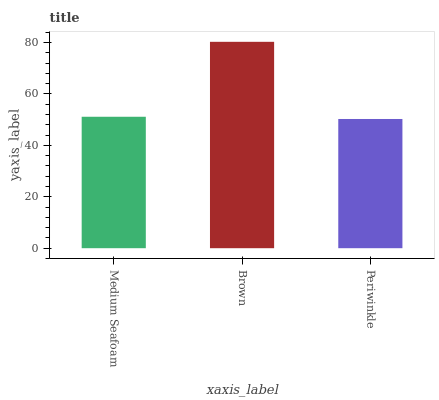Is Periwinkle the minimum?
Answer yes or no. Yes. Is Brown the maximum?
Answer yes or no. Yes. Is Brown the minimum?
Answer yes or no. No. Is Periwinkle the maximum?
Answer yes or no. No. Is Brown greater than Periwinkle?
Answer yes or no. Yes. Is Periwinkle less than Brown?
Answer yes or no. Yes. Is Periwinkle greater than Brown?
Answer yes or no. No. Is Brown less than Periwinkle?
Answer yes or no. No. Is Medium Seafoam the high median?
Answer yes or no. Yes. Is Medium Seafoam the low median?
Answer yes or no. Yes. Is Periwinkle the high median?
Answer yes or no. No. Is Periwinkle the low median?
Answer yes or no. No. 